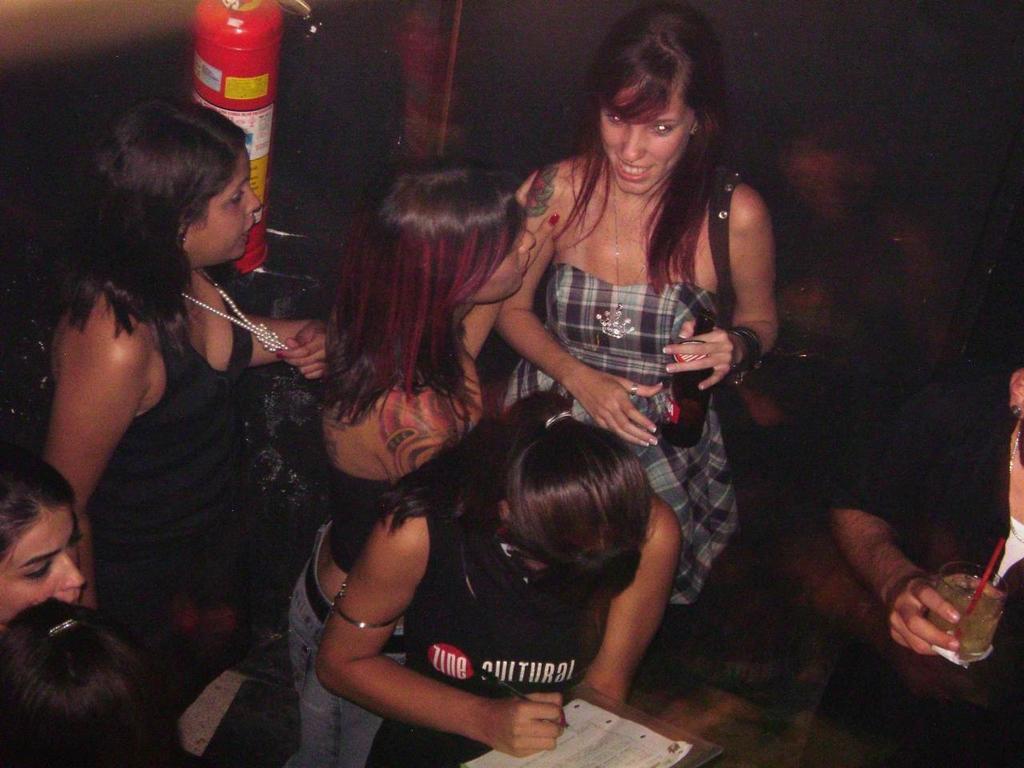In one or two sentences, can you explain what this image depicts? In this image, I can see a group of people standing. At the top of the image, I can see a fire extinguisher attached to the wall. 